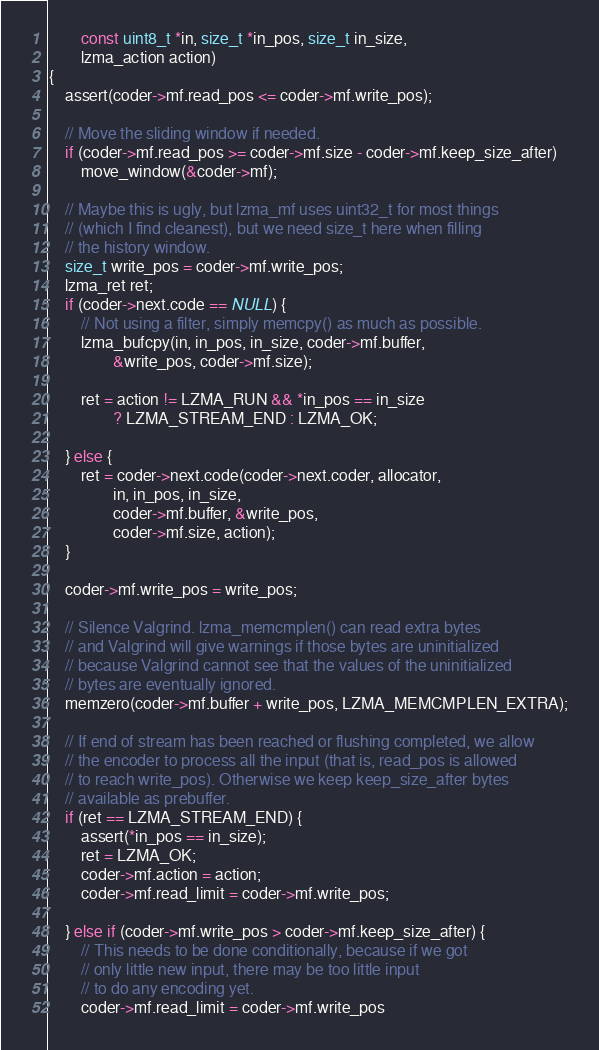<code> <loc_0><loc_0><loc_500><loc_500><_C_>		const uint8_t *in, size_t *in_pos, size_t in_size,
		lzma_action action)
{
	assert(coder->mf.read_pos <= coder->mf.write_pos);

	// Move the sliding window if needed.
	if (coder->mf.read_pos >= coder->mf.size - coder->mf.keep_size_after)
		move_window(&coder->mf);

	// Maybe this is ugly, but lzma_mf uses uint32_t for most things
	// (which I find cleanest), but we need size_t here when filling
	// the history window.
	size_t write_pos = coder->mf.write_pos;
	lzma_ret ret;
	if (coder->next.code == NULL) {
		// Not using a filter, simply memcpy() as much as possible.
		lzma_bufcpy(in, in_pos, in_size, coder->mf.buffer,
				&write_pos, coder->mf.size);

		ret = action != LZMA_RUN && *in_pos == in_size
				? LZMA_STREAM_END : LZMA_OK;

	} else {
		ret = coder->next.code(coder->next.coder, allocator,
				in, in_pos, in_size,
				coder->mf.buffer, &write_pos,
				coder->mf.size, action);
	}

	coder->mf.write_pos = write_pos;

	// Silence Valgrind. lzma_memcmplen() can read extra bytes
	// and Valgrind will give warnings if those bytes are uninitialized
	// because Valgrind cannot see that the values of the uninitialized
	// bytes are eventually ignored.
	memzero(coder->mf.buffer + write_pos, LZMA_MEMCMPLEN_EXTRA);

	// If end of stream has been reached or flushing completed, we allow
	// the encoder to process all the input (that is, read_pos is allowed
	// to reach write_pos). Otherwise we keep keep_size_after bytes
	// available as prebuffer.
	if (ret == LZMA_STREAM_END) {
		assert(*in_pos == in_size);
		ret = LZMA_OK;
		coder->mf.action = action;
		coder->mf.read_limit = coder->mf.write_pos;

	} else if (coder->mf.write_pos > coder->mf.keep_size_after) {
		// This needs to be done conditionally, because if we got
		// only little new input, there may be too little input
		// to do any encoding yet.
		coder->mf.read_limit = coder->mf.write_pos</code> 